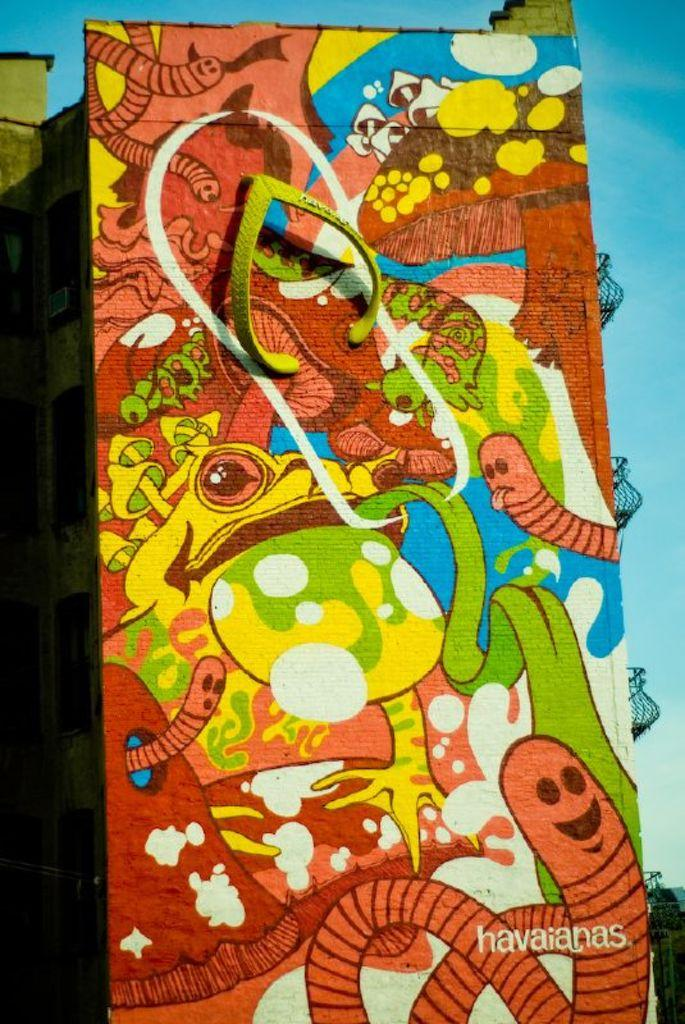<image>
Present a compact description of the photo's key features. a painting of worms and frogs by havaianas. 